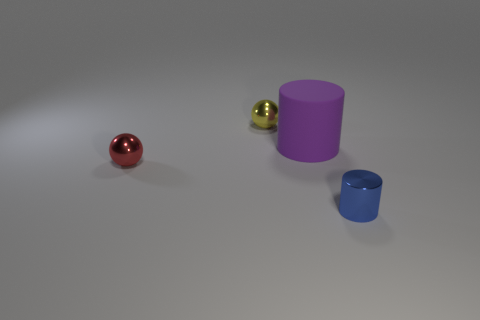Add 4 yellow balls. How many objects exist? 8 Add 4 blue metallic objects. How many blue metallic objects exist? 5 Subtract 0 red cylinders. How many objects are left? 4 Subtract all purple cylinders. Subtract all blue metallic things. How many objects are left? 2 Add 1 yellow metal things. How many yellow metal things are left? 2 